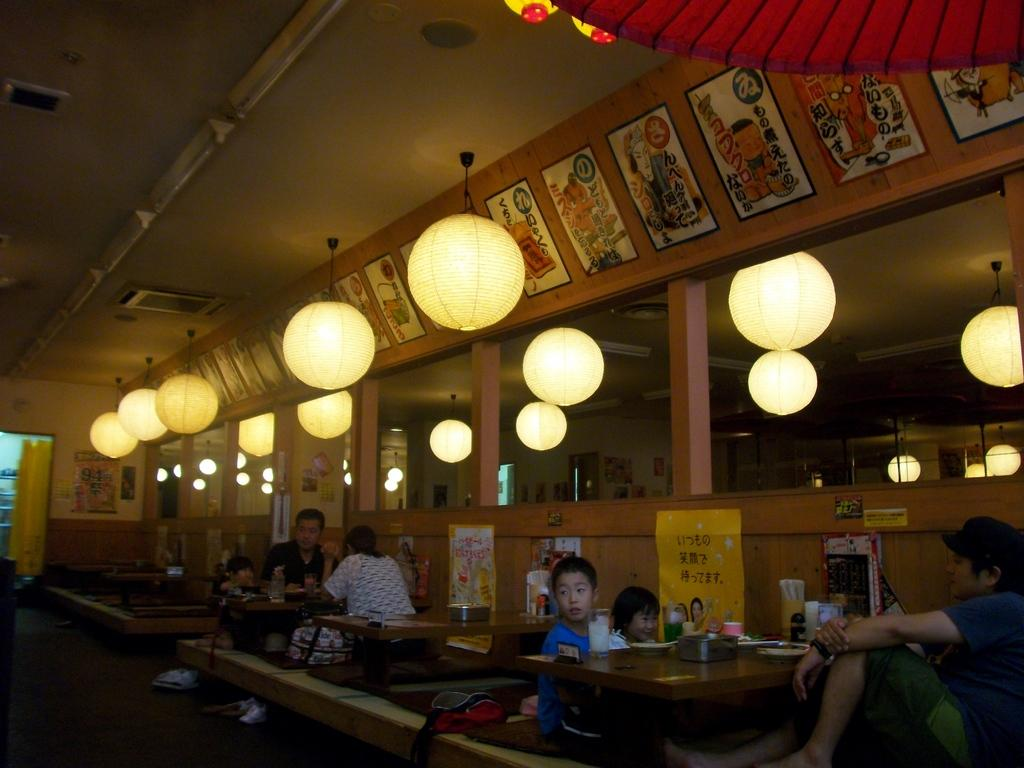What are the people in the image doing? The people in the image are sitting on chairs. What type of furniture is present in the image besides chairs? There are tables in the image. What type of plantation is visible in the image? There is no plantation present in the image. What type of sorting activity is taking place in the image? There is no sorting activity visible in the image. 